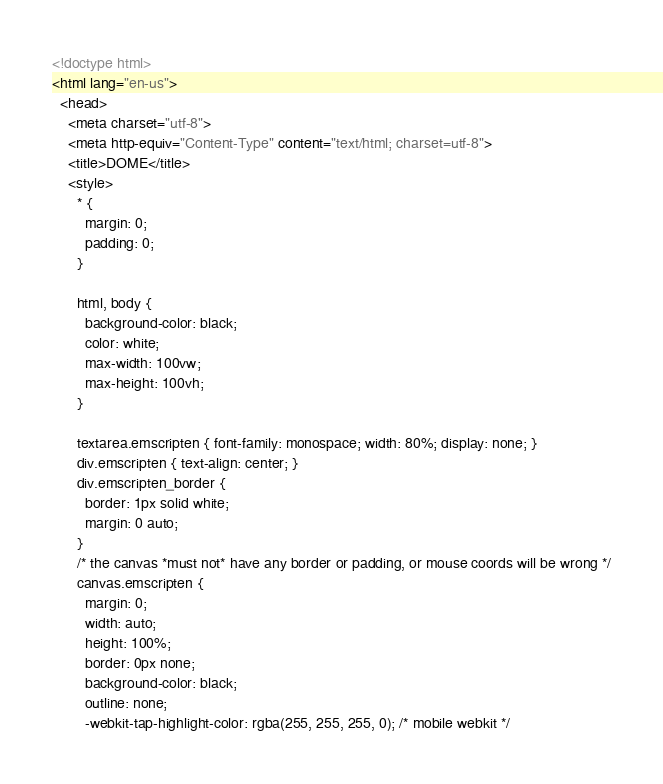Convert code to text. <code><loc_0><loc_0><loc_500><loc_500><_HTML_><!doctype html>
<html lang="en-us">
  <head>
    <meta charset="utf-8">
    <meta http-equiv="Content-Type" content="text/html; charset=utf-8">
    <title>DOME</title>
    <style>
      * { 
        margin: 0;
        padding: 0; 
      }

      html, body { 
        background-color: black;
        color: white;
        max-width: 100vw;
        max-height: 100vh;
      }

      textarea.emscripten { font-family: monospace; width: 80%; display: none; }
      div.emscripten { text-align: center; }
      div.emscripten_border {
        border: 1px solid white; 
        margin: 0 auto;
      }
      /* the canvas *must not* have any border or padding, or mouse coords will be wrong */
      canvas.emscripten { 
        margin: 0;
        width: auto;
        height: 100%;
        border: 0px none; 
        background-color: black; 
        outline: none;
        -webkit-tap-highlight-color: rgba(255, 255, 255, 0); /* mobile webkit */</code> 